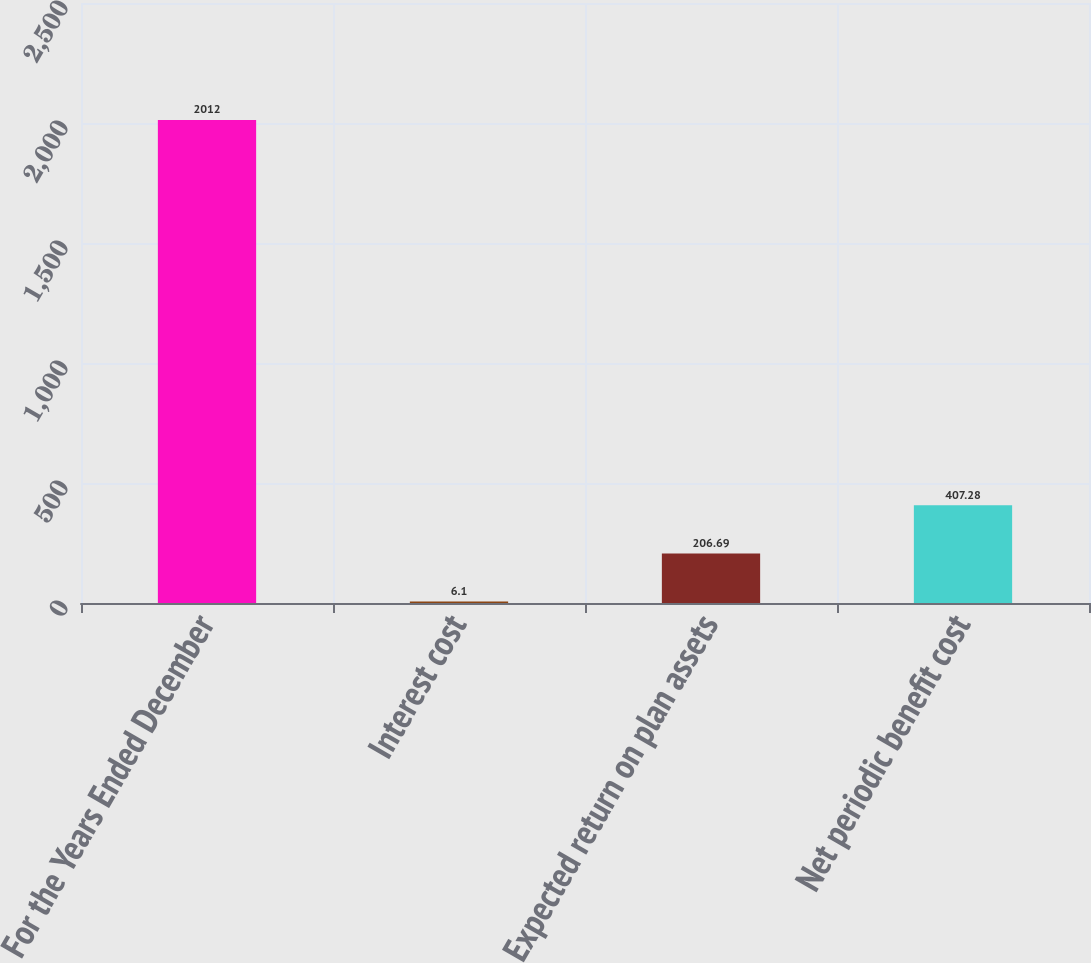<chart> <loc_0><loc_0><loc_500><loc_500><bar_chart><fcel>For the Years Ended December<fcel>Interest cost<fcel>Expected return on plan assets<fcel>Net periodic benefit cost<nl><fcel>2012<fcel>6.1<fcel>206.69<fcel>407.28<nl></chart> 